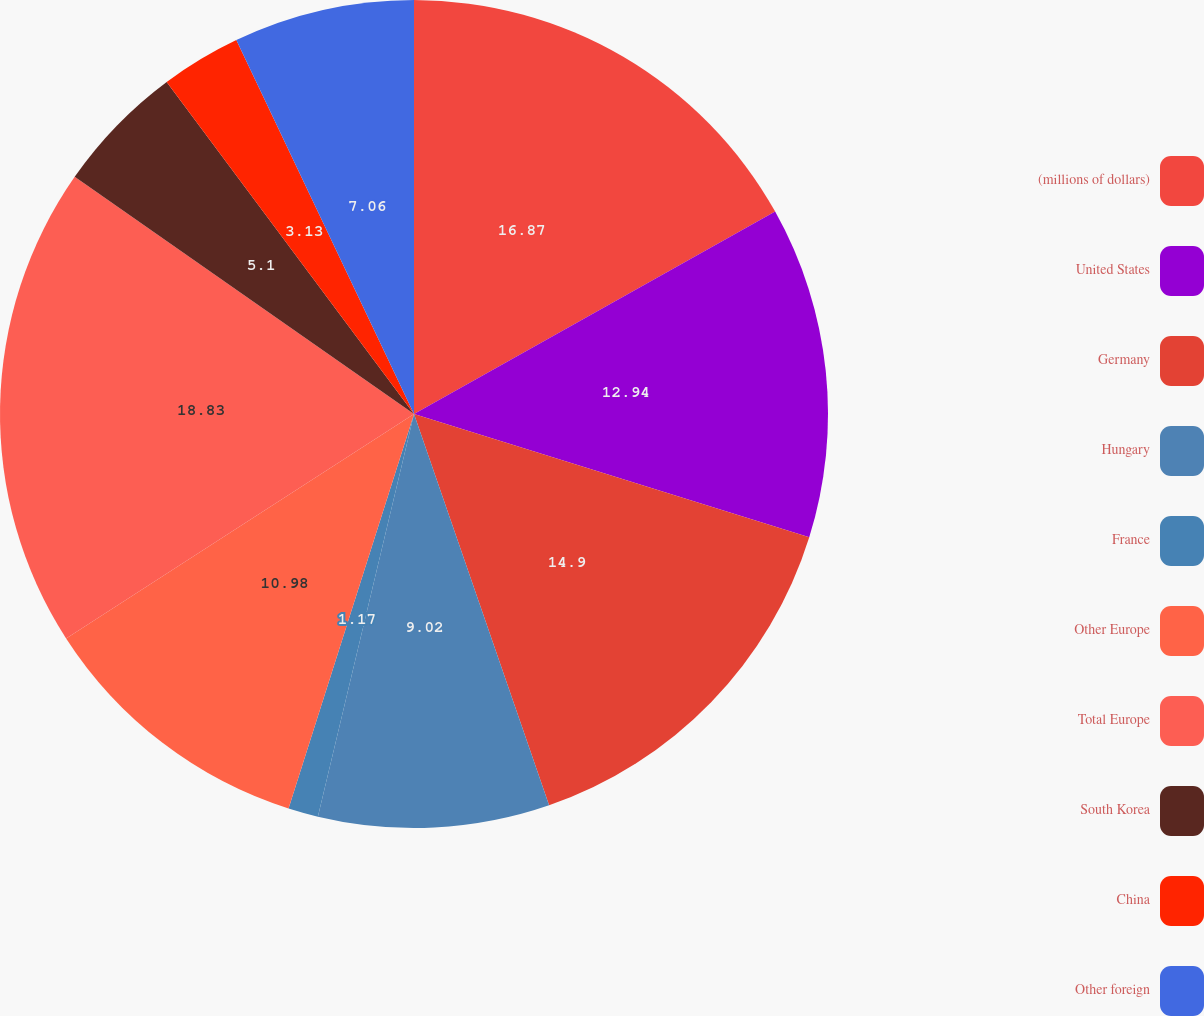Convert chart. <chart><loc_0><loc_0><loc_500><loc_500><pie_chart><fcel>(millions of dollars)<fcel>United States<fcel>Germany<fcel>Hungary<fcel>France<fcel>Other Europe<fcel>Total Europe<fcel>South Korea<fcel>China<fcel>Other foreign<nl><fcel>16.87%<fcel>12.94%<fcel>14.9%<fcel>9.02%<fcel>1.17%<fcel>10.98%<fcel>18.83%<fcel>5.1%<fcel>3.13%<fcel>7.06%<nl></chart> 